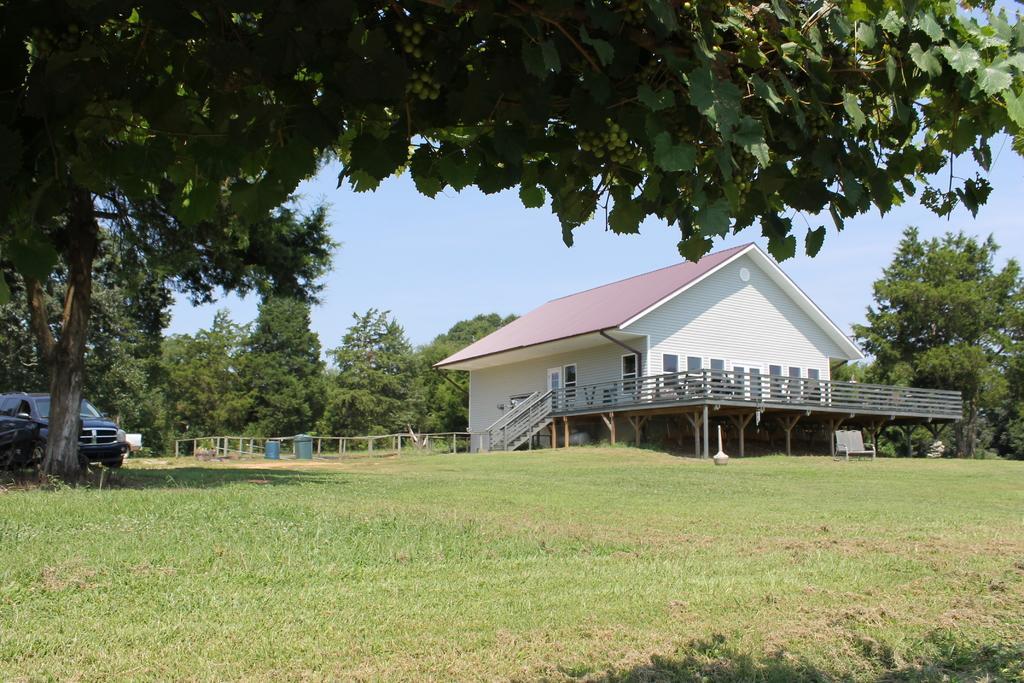Describe this image in one or two sentences. In this image there is a house, railing, trees, grass, chair, vehicle, sky and objects. Land is covered with grass.  